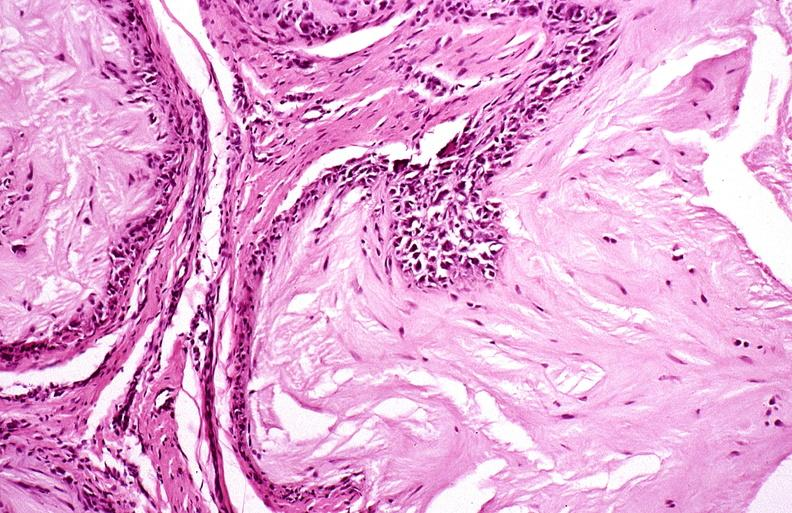what is present?
Answer the question using a single word or phrase. Joints 